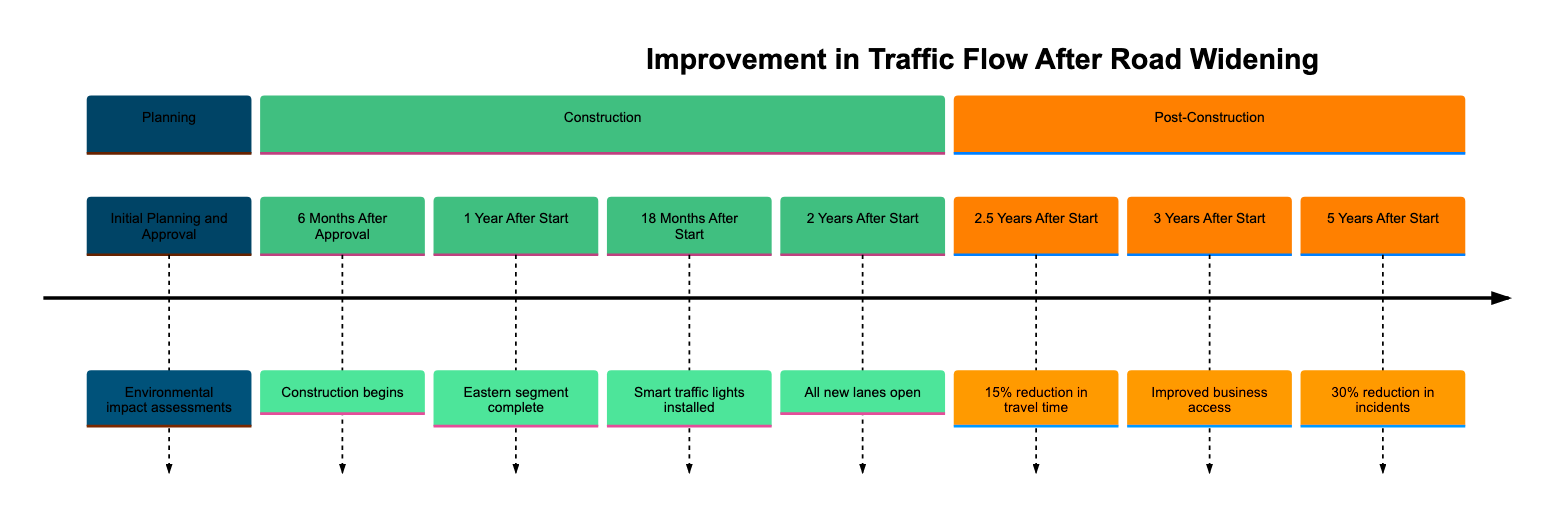What is the first step in the timeline? The first step in the timeline is "Initial Planning and Approval," where the local government outlines the need for road widening.
Answer: Initial Planning and Approval How many months after approval does construction begin? Construction begins 6 months after the approval, which is explicitly stated in the timeline.
Answer: 6 months What significant measure was implemented 18 months after the start of construction? At 18 months, smart traffic lights were installed, facilitating better flow and reducing vehicle idling on the widened segments.
Answer: Smart traffic lights What percentage reduction in travel time was reported 2.5 years after construction? Surveys conducted at this point revealed a travel time reduction of 15% compared to pre-construction levels, as indicated in the timeline.
Answer: 15% What was reported by local businesses 3 years after the start of construction? Local businesses reported improved access and an increase in customer traffic due to the reduced congestion on Main Street.
Answer: Improved access What percentage reduction in traffic-related incidents was noted 5 years after construction? The annual traffic report indicated a 30% reduction in traffic-related incidents on Main Street and neighboring routes.
Answer: 30% 